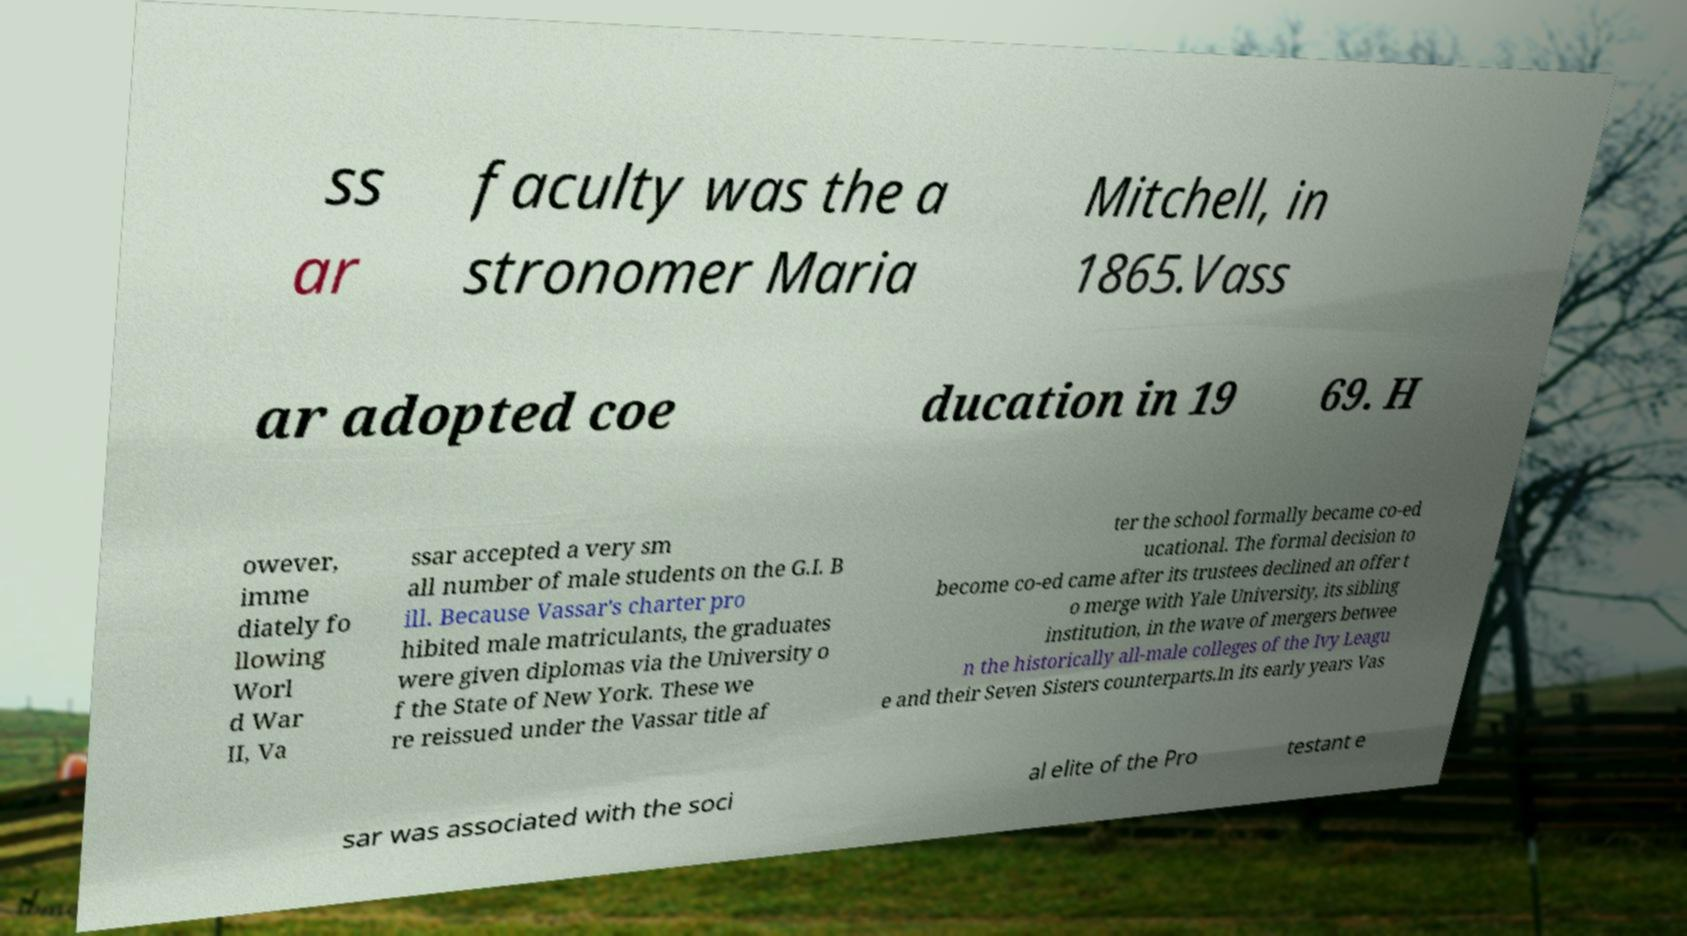Please read and relay the text visible in this image. What does it say? ss ar faculty was the a stronomer Maria Mitchell, in 1865.Vass ar adopted coe ducation in 19 69. H owever, imme diately fo llowing Worl d War II, Va ssar accepted a very sm all number of male students on the G.I. B ill. Because Vassar's charter pro hibited male matriculants, the graduates were given diplomas via the University o f the State of New York. These we re reissued under the Vassar title af ter the school formally became co-ed ucational. The formal decision to become co-ed came after its trustees declined an offer t o merge with Yale University, its sibling institution, in the wave of mergers betwee n the historically all-male colleges of the Ivy Leagu e and their Seven Sisters counterparts.In its early years Vas sar was associated with the soci al elite of the Pro testant e 